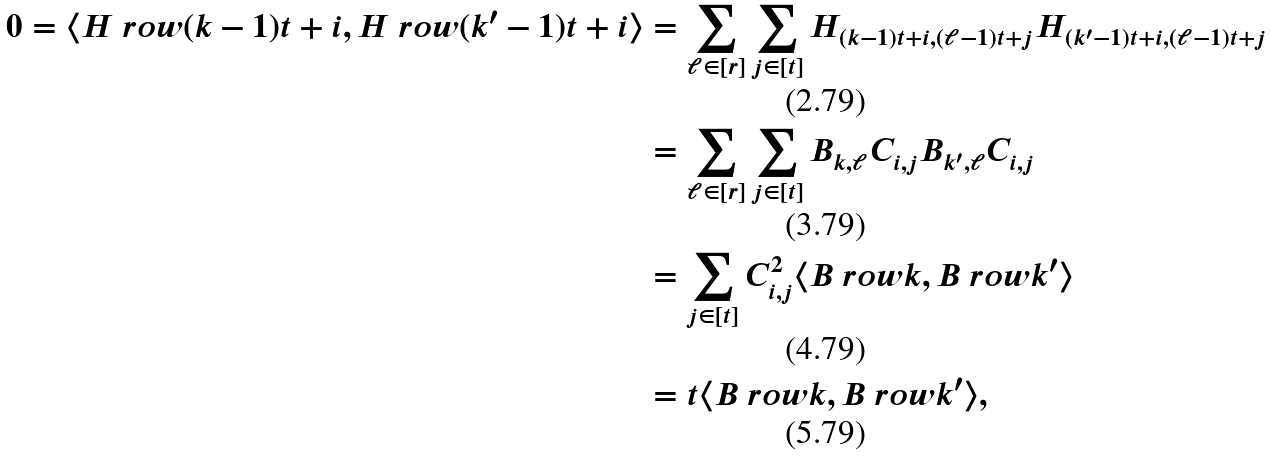<formula> <loc_0><loc_0><loc_500><loc_500>0 = \langle H \ r o w { ( k - 1 ) t + i } , H \ r o w { ( k ^ { \prime } - 1 ) t + i } \rangle & = \sum _ { \ell \in [ r ] } \sum _ { j \in [ t ] } H _ { ( k - 1 ) t + i , ( \ell - 1 ) t + j } H _ { ( k ^ { \prime } - 1 ) t + i , ( \ell - 1 ) t + j } \\ & = \sum _ { \ell \in [ r ] } \sum _ { j \in [ t ] } B _ { k , \ell } C _ { i , j } B _ { k ^ { \prime } , \ell } C _ { i , j } \\ & = \sum _ { j \in [ t ] } C _ { i , j } ^ { 2 } \langle B \ r o w { k } , B \ r o w { k ^ { \prime } } \rangle \\ & = t \langle B \ r o w { k } , B \ r o w { k ^ { \prime } } \rangle ,</formula> 